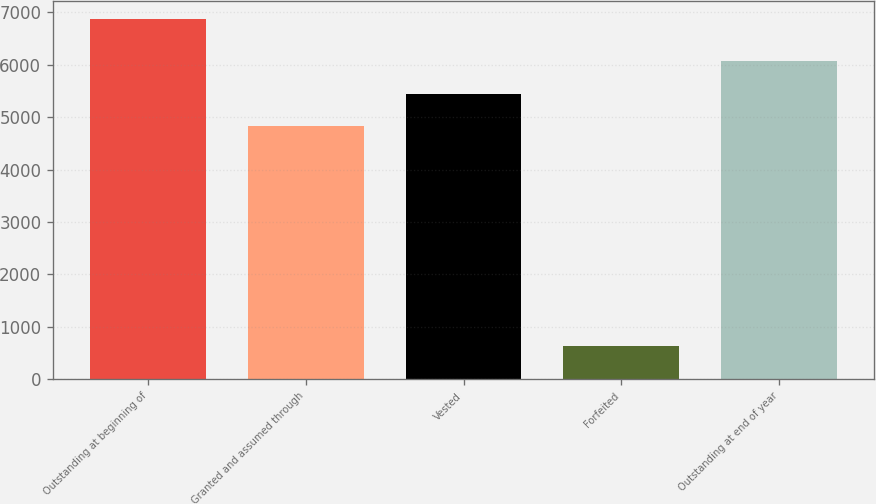Convert chart. <chart><loc_0><loc_0><loc_500><loc_500><bar_chart><fcel>Outstanding at beginning of<fcel>Granted and assumed through<fcel>Vested<fcel>Forfeited<fcel>Outstanding at end of year<nl><fcel>6864<fcel>4821<fcel>5443.9<fcel>635<fcel>6066.8<nl></chart> 